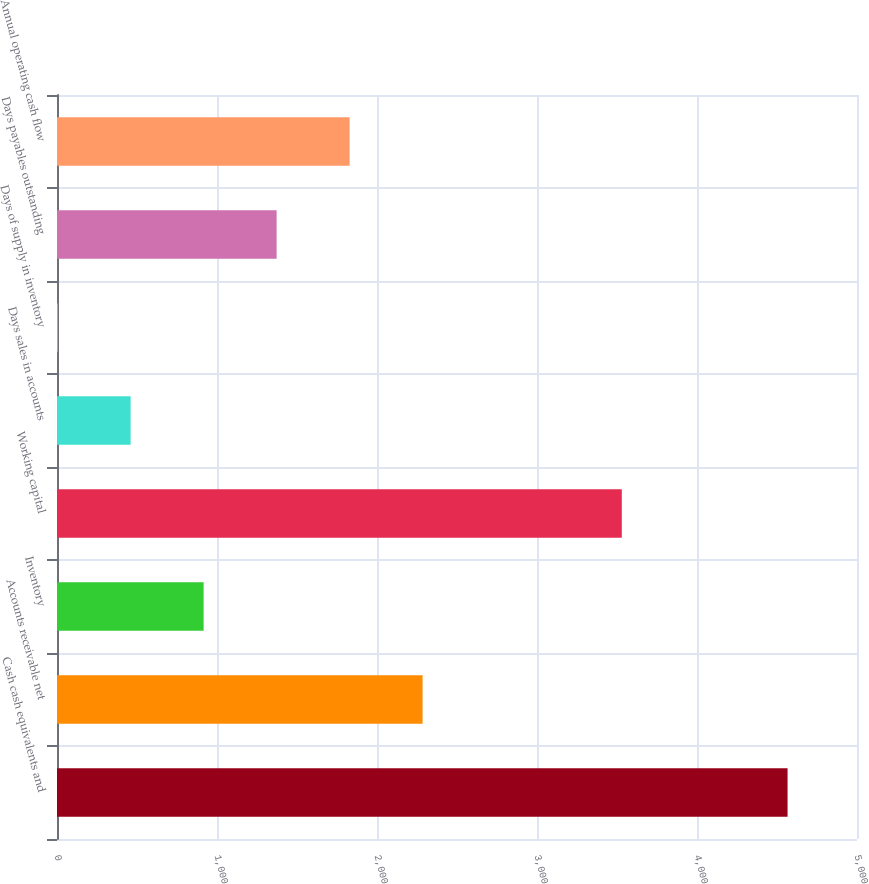Convert chart. <chart><loc_0><loc_0><loc_500><loc_500><bar_chart><fcel>Cash cash equivalents and<fcel>Accounts receivable net<fcel>Inventory<fcel>Working capital<fcel>Days sales in accounts<fcel>Days of supply in inventory<fcel>Days payables outstanding<fcel>Annual operating cash flow<nl><fcel>4566<fcel>2285<fcel>916.4<fcel>3530<fcel>460.2<fcel>4<fcel>1372.6<fcel>1828.8<nl></chart> 